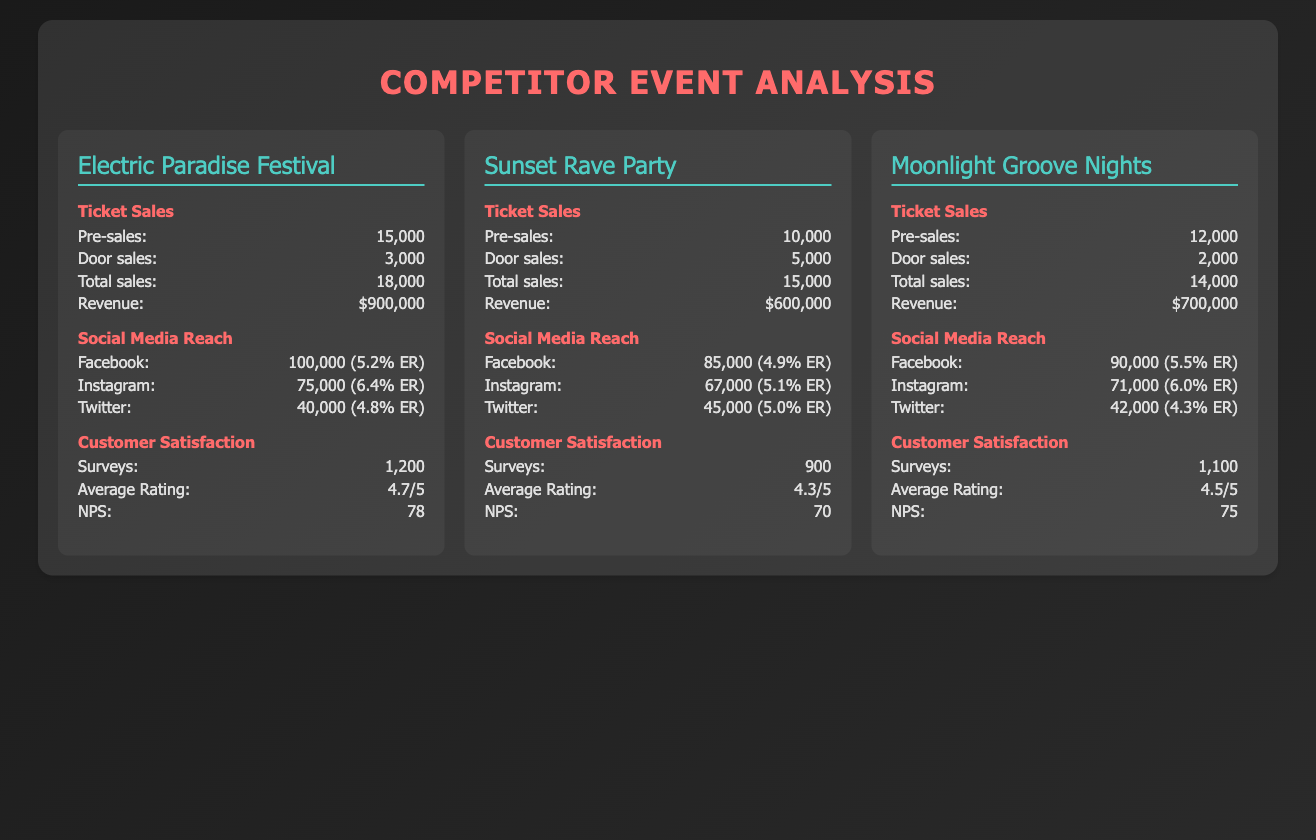What is the total ticket sales for the Electric Paradise Festival? The total ticket sales for the Electric Paradise Festival is given directly in the document as 18,000.
Answer: 18,000 What was the average rating of the Sunset Rave Party? The average rating for the Sunset Rave Party is stated in the document as 4.3/5.
Answer: 4.3/5 Which event had the highest revenue? The revenue for Electric Paradise Festival is $900,000, which is higher than the other events.
Answer: $900,000 What is the NPS for Moonlight Groove Nights? The NPS for Moonlight Groove Nights, as listed in the document, is 75.
Answer: 75 Which social media platform had the highest reach for the Sunset Rave Party? The Facebook reach for Sunset Rave Party is stated as 85,000, which is the highest among its social media platforms.
Answer: Facebook How many surveys were conducted for the Electric Paradise Festival? The document states that 1,200 surveys were conducted for the Electric Paradise Festival.
Answer: 1,200 What was the total revenue from door sales for Moonlight Groove Nights? The door sales for Moonlight Groove Nights are explicitly listed as 2,000, and multiplying by an assumed ticket price, we can't determine the revenue without that information.
Answer: $700,000 How many pre-sales tickets were sold for the Sunset Rave Party? The number of pre-sales tickets for the Sunset Rave Party is shown in the document as 10,000.
Answer: 10,000 